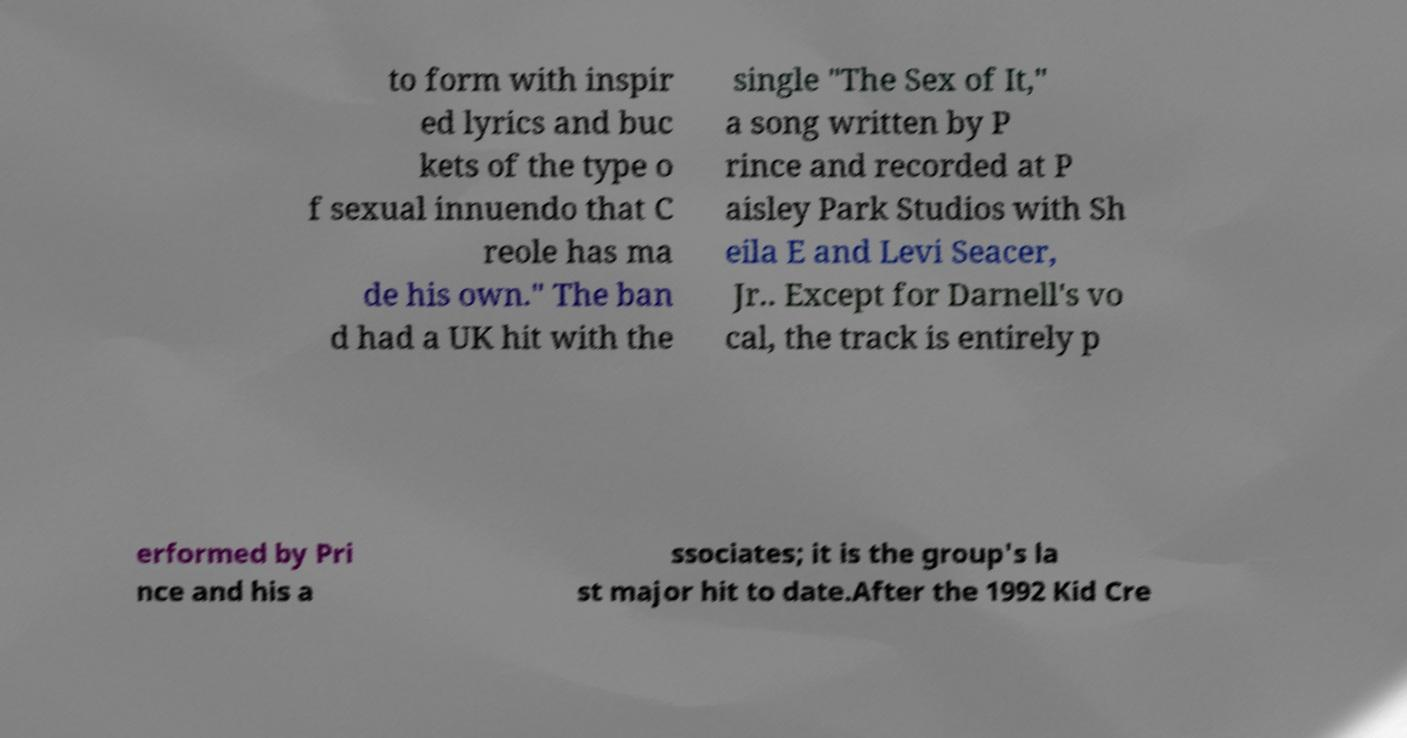Can you read and provide the text displayed in the image?This photo seems to have some interesting text. Can you extract and type it out for me? to form with inspir ed lyrics and buc kets of the type o f sexual innuendo that C reole has ma de his own." The ban d had a UK hit with the single "The Sex of It," a song written by P rince and recorded at P aisley Park Studios with Sh eila E and Levi Seacer, Jr.. Except for Darnell's vo cal, the track is entirely p erformed by Pri nce and his a ssociates; it is the group's la st major hit to date.After the 1992 Kid Cre 